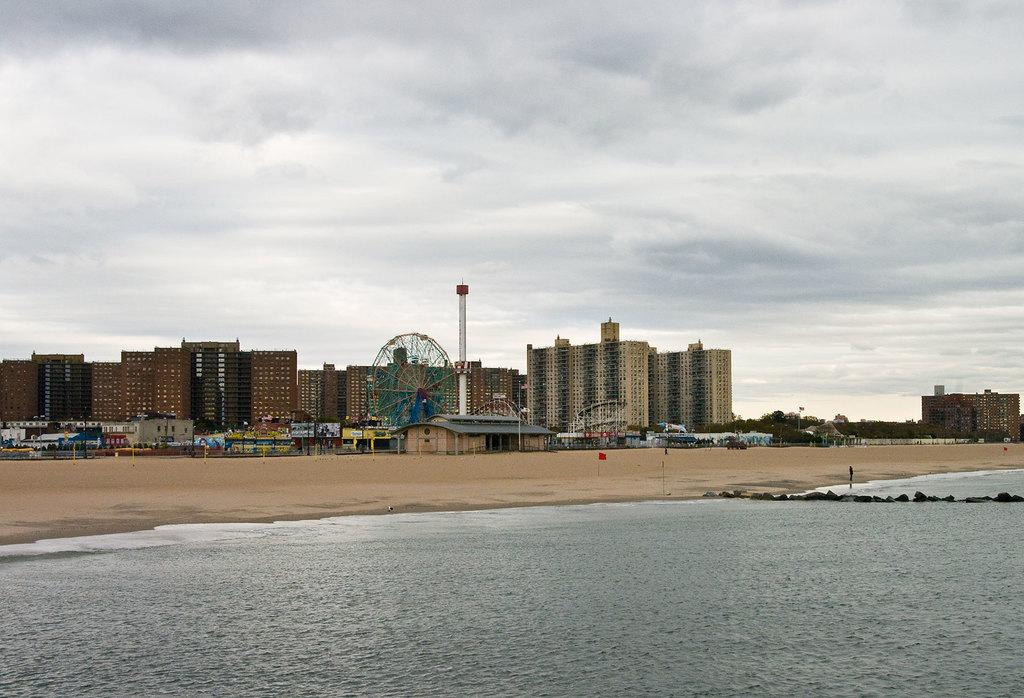What is located in the center of the image? There are buildings, stalls, and poles in the center of the image. What can be found near the river at the bottom of the image? The river is at the bottom of the image, and there are no specific details about what is near it. What is visible in the background of the image? The sky is visible in the background of the image. What type of hand can be seen holding a sack in the image? There is no hand or sack present in the image. What kind of flesh is visible on the poles in the image? There is no flesh visible on the poles in the image; they are likely made of metal or wood. 